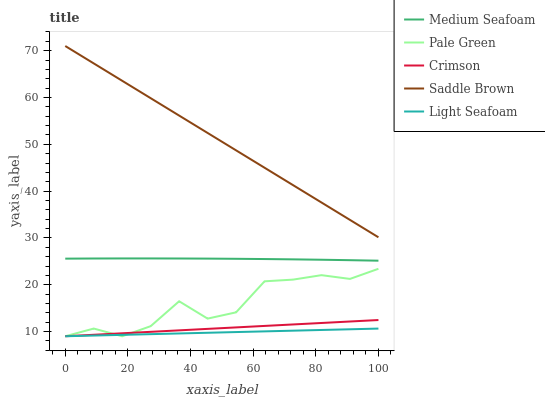Does Light Seafoam have the minimum area under the curve?
Answer yes or no. Yes. Does Saddle Brown have the maximum area under the curve?
Answer yes or no. Yes. Does Pale Green have the minimum area under the curve?
Answer yes or no. No. Does Pale Green have the maximum area under the curve?
Answer yes or no. No. Is Crimson the smoothest?
Answer yes or no. Yes. Is Pale Green the roughest?
Answer yes or no. Yes. Is Medium Seafoam the smoothest?
Answer yes or no. No. Is Medium Seafoam the roughest?
Answer yes or no. No. Does Crimson have the lowest value?
Answer yes or no. Yes. Does Medium Seafoam have the lowest value?
Answer yes or no. No. Does Saddle Brown have the highest value?
Answer yes or no. Yes. Does Pale Green have the highest value?
Answer yes or no. No. Is Light Seafoam less than Saddle Brown?
Answer yes or no. Yes. Is Medium Seafoam greater than Pale Green?
Answer yes or no. Yes. Does Crimson intersect Light Seafoam?
Answer yes or no. Yes. Is Crimson less than Light Seafoam?
Answer yes or no. No. Is Crimson greater than Light Seafoam?
Answer yes or no. No. Does Light Seafoam intersect Saddle Brown?
Answer yes or no. No. 